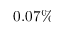Convert formula to latex. <formula><loc_0><loc_0><loc_500><loc_500>0 . 0 7 \%</formula> 